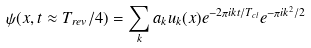<formula> <loc_0><loc_0><loc_500><loc_500>\psi ( x , t \approx T _ { r e v } / 4 ) = \sum _ { k } a _ { k } u _ { k } ( x ) e ^ { - 2 \pi i k t / T _ { c l } } e ^ { - \pi i k ^ { 2 } / 2 }</formula> 